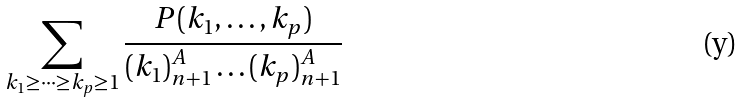Convert formula to latex. <formula><loc_0><loc_0><loc_500><loc_500>\sum _ { k _ { 1 } \geq \dots \geq k _ { p } \geq 1 } \frac { P ( k _ { 1 } , \dots , k _ { p } ) } { ( k _ { 1 } ) _ { n + 1 } ^ { A } \dots ( k _ { p } ) _ { n + 1 } ^ { A } }</formula> 